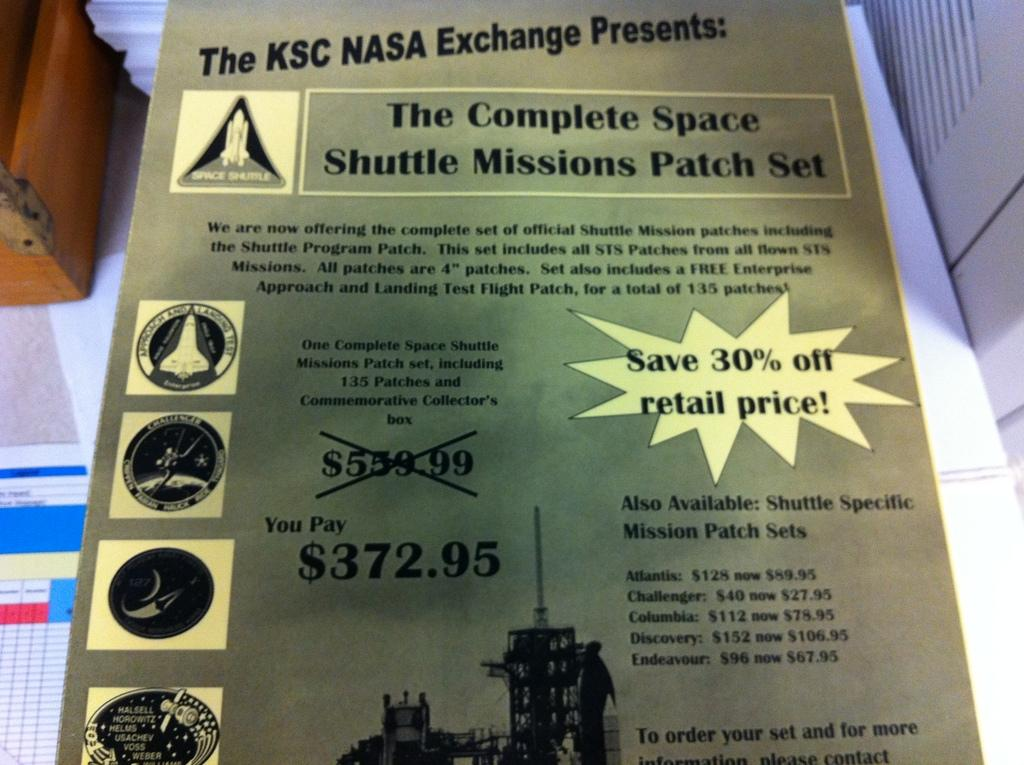<image>
Create a compact narrative representing the image presented. An ad from The KSC NASA Exchange introducing The Complete Space Shuttle Missions Patch Set 